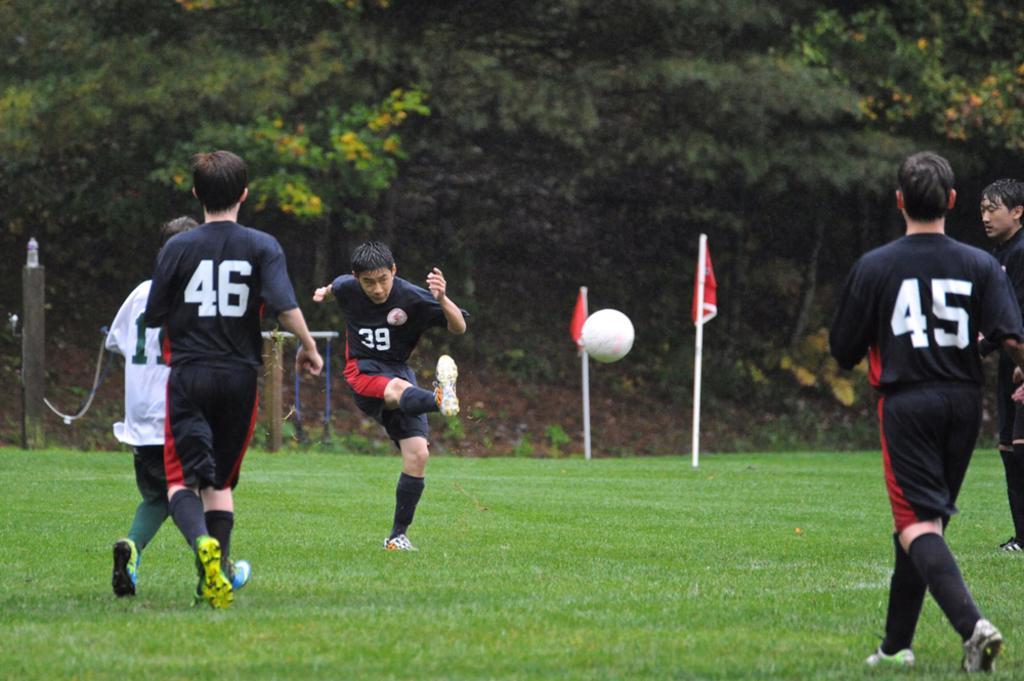Could you give a brief overview of what you see in this image? In this image we can see some players on the ground. We can see the flags and wooden poles. We can see the surrounding trees. 